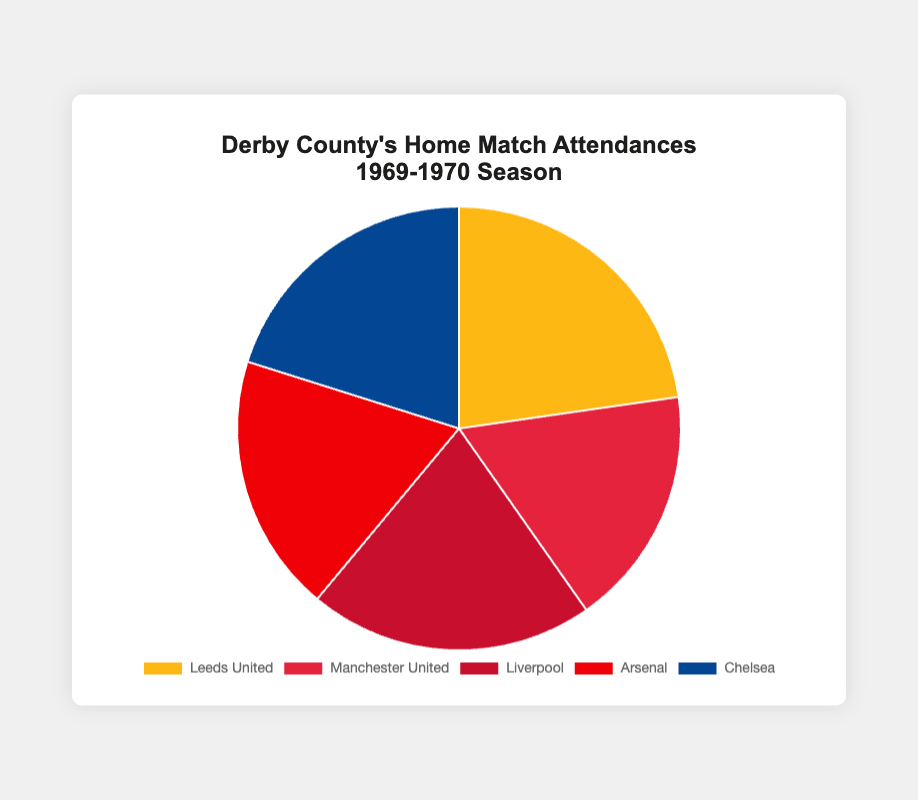Which match had the highest attendance? From the pie chart, you can see that the largest segment represents the match against Leeds United. The size of this segment indicates it had the highest attendance.
Answer: Leeds United Which match had the lowest attendance? The smallest segment on the pie chart corresponds to the match against Manchester United.
Answer: Manchester United What is the total attendance for all matches combined? To find the total attendance, sum up the values for each match: 35000 (Leeds United) + 27000 (Manchester United) + 32000 (Liverpool) + 29000 (Arsenal) + 31000 (Chelsea) = 154000.
Answer: 154000 How much greater was the attendance for the match against Leeds United compared to Manchester United? Subtract the attendance for Manchester United from that for Leeds United: 35000 - 27000 = 8000.
Answer: 8000 What is the average attendance for these matches? Calculate the total attendance and divide by the number of matches: (35000 + 27000 + 32000 + 29000 + 31000) / 5 = 154000 / 5 = 30800.
Answer: 30800 Which matches had attendances greater than 30000? From the pie chart, Leeds United (35000), Liverpool (32000), and Chelsea (31000) all had attendances greater than 30000.
Answer: Leeds United, Liverpool, Chelsea How does the attendance for the match against Arsenal compare to the one against Chelsea? The pie chart shows the segments for Arsenal and Chelsea. Comparing their sizes, the attendance for Arsenal (29000) is less than that for Chelsea (31000).
Answer: Less What percentage of the total attendance does the match against Liverpool represent? First, find the total attendance, which is 154000. Then, divide Liverpool's attendance by the total and multiply by 100 to get the percentage: (32000 / 154000) * 100 ≈ 20.78%.
Answer: 20.78% What is the difference between the highest and the lowest attendances? Subtract the lowest attendance (Manchester United, 27000) from the highest attendance (Leeds United, 35000): 35000 - 27000 = 8000.
Answer: 8000 